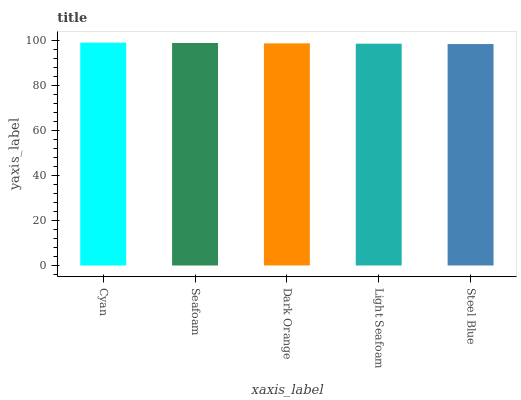Is Steel Blue the minimum?
Answer yes or no. Yes. Is Cyan the maximum?
Answer yes or no. Yes. Is Seafoam the minimum?
Answer yes or no. No. Is Seafoam the maximum?
Answer yes or no. No. Is Cyan greater than Seafoam?
Answer yes or no. Yes. Is Seafoam less than Cyan?
Answer yes or no. Yes. Is Seafoam greater than Cyan?
Answer yes or no. No. Is Cyan less than Seafoam?
Answer yes or no. No. Is Dark Orange the high median?
Answer yes or no. Yes. Is Dark Orange the low median?
Answer yes or no. Yes. Is Cyan the high median?
Answer yes or no. No. Is Seafoam the low median?
Answer yes or no. No. 